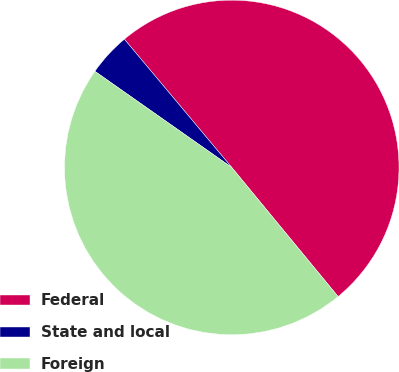Convert chart. <chart><loc_0><loc_0><loc_500><loc_500><pie_chart><fcel>Federal<fcel>State and local<fcel>Foreign<nl><fcel>50.13%<fcel>4.16%<fcel>45.71%<nl></chart> 